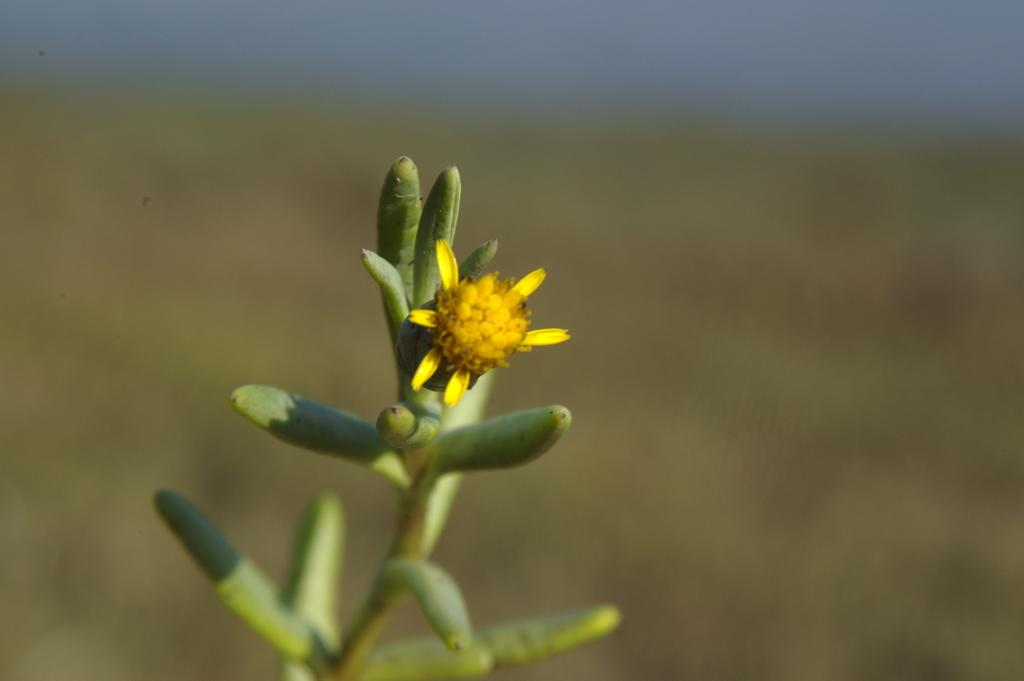What type of flower is in the image? There is a small yellow flower in the image. What color is the plant that the flower is on? The flower is on a green plant. Can you describe the background of the image? The background of the image is blurred. What type of soup is being served in the image? There is no soup present in the image; it features a small yellow flower on a green plant. What type of grain is visible in the image? There is no grain present in the image; it features a small yellow flower on a green plant. 